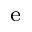<formula> <loc_0><loc_0><loc_500><loc_500>_ { e }</formula> 